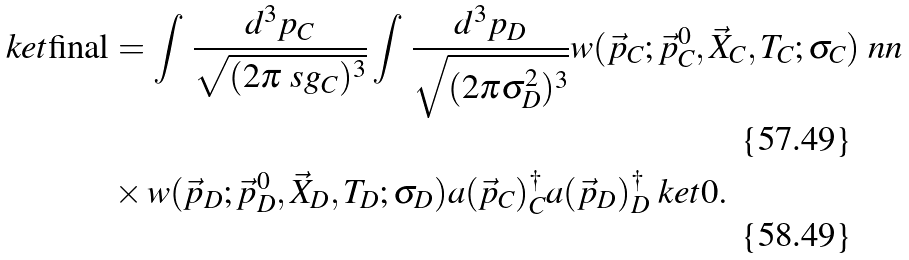Convert formula to latex. <formula><loc_0><loc_0><loc_500><loc_500>\ k e t { \text {final} } & = \int \, \frac { d ^ { 3 } p _ { C } } { \sqrt { ( 2 \pi \ s g _ { C } ) ^ { 3 } } } \int \, { { \frac { { d ^ { 3 } p _ { D } } } { { \sqrt { ( 2 \pi \sigma _ { D } ^ { 2 } ) ^ { 3 } } } } } } w ( { \vec { p } } _ { C } ; { \vec { p } } _ { C } ^ { 0 } , { \vec { X } } _ { C } , T _ { C } ; \sigma _ { C } ) \ n n \\ & \times w ( { \vec { p } } _ { D } ; { \vec { p } } _ { D } ^ { 0 } , { \vec { X } } _ { D } , T _ { D } ; \sigma _ { D } ) a ( \vec { p } _ { C } ) _ { C } ^ { \dagger } a ( \vec { p } _ { D } ) _ { D } ^ { \dagger } \ k e t { 0 } .</formula> 